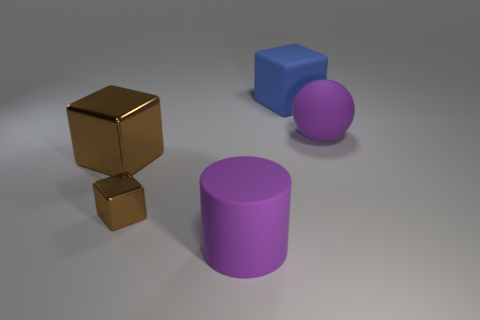Add 4 small metallic blocks. How many objects exist? 9 Subtract all cubes. How many objects are left? 2 Subtract 0 cyan cubes. How many objects are left? 5 Subtract all yellow matte balls. Subtract all cubes. How many objects are left? 2 Add 2 big brown metal cubes. How many big brown metal cubes are left? 3 Add 3 small green objects. How many small green objects exist? 3 